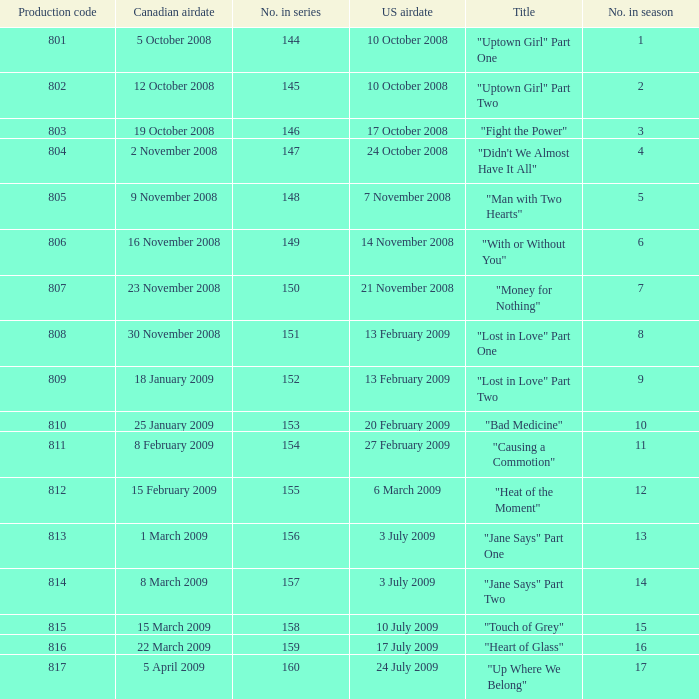How many U.S. air dates were from an episode in Season 4? 1.0. 